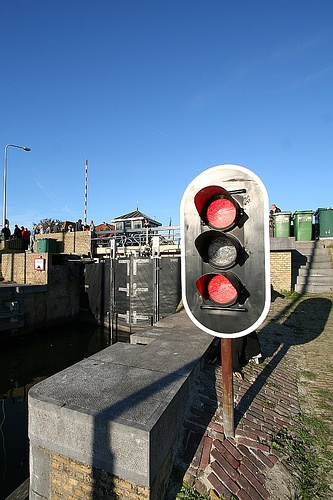Describe the objects in this image and their specific colors. I can see traffic light in blue, white, gray, black, and darkgray tones, people in blue, black, maroon, gray, and brown tones, people in blue, black, darkgray, gray, and beige tones, people in blue, black, gray, and maroon tones, and people in blue, black, and gray tones in this image. 